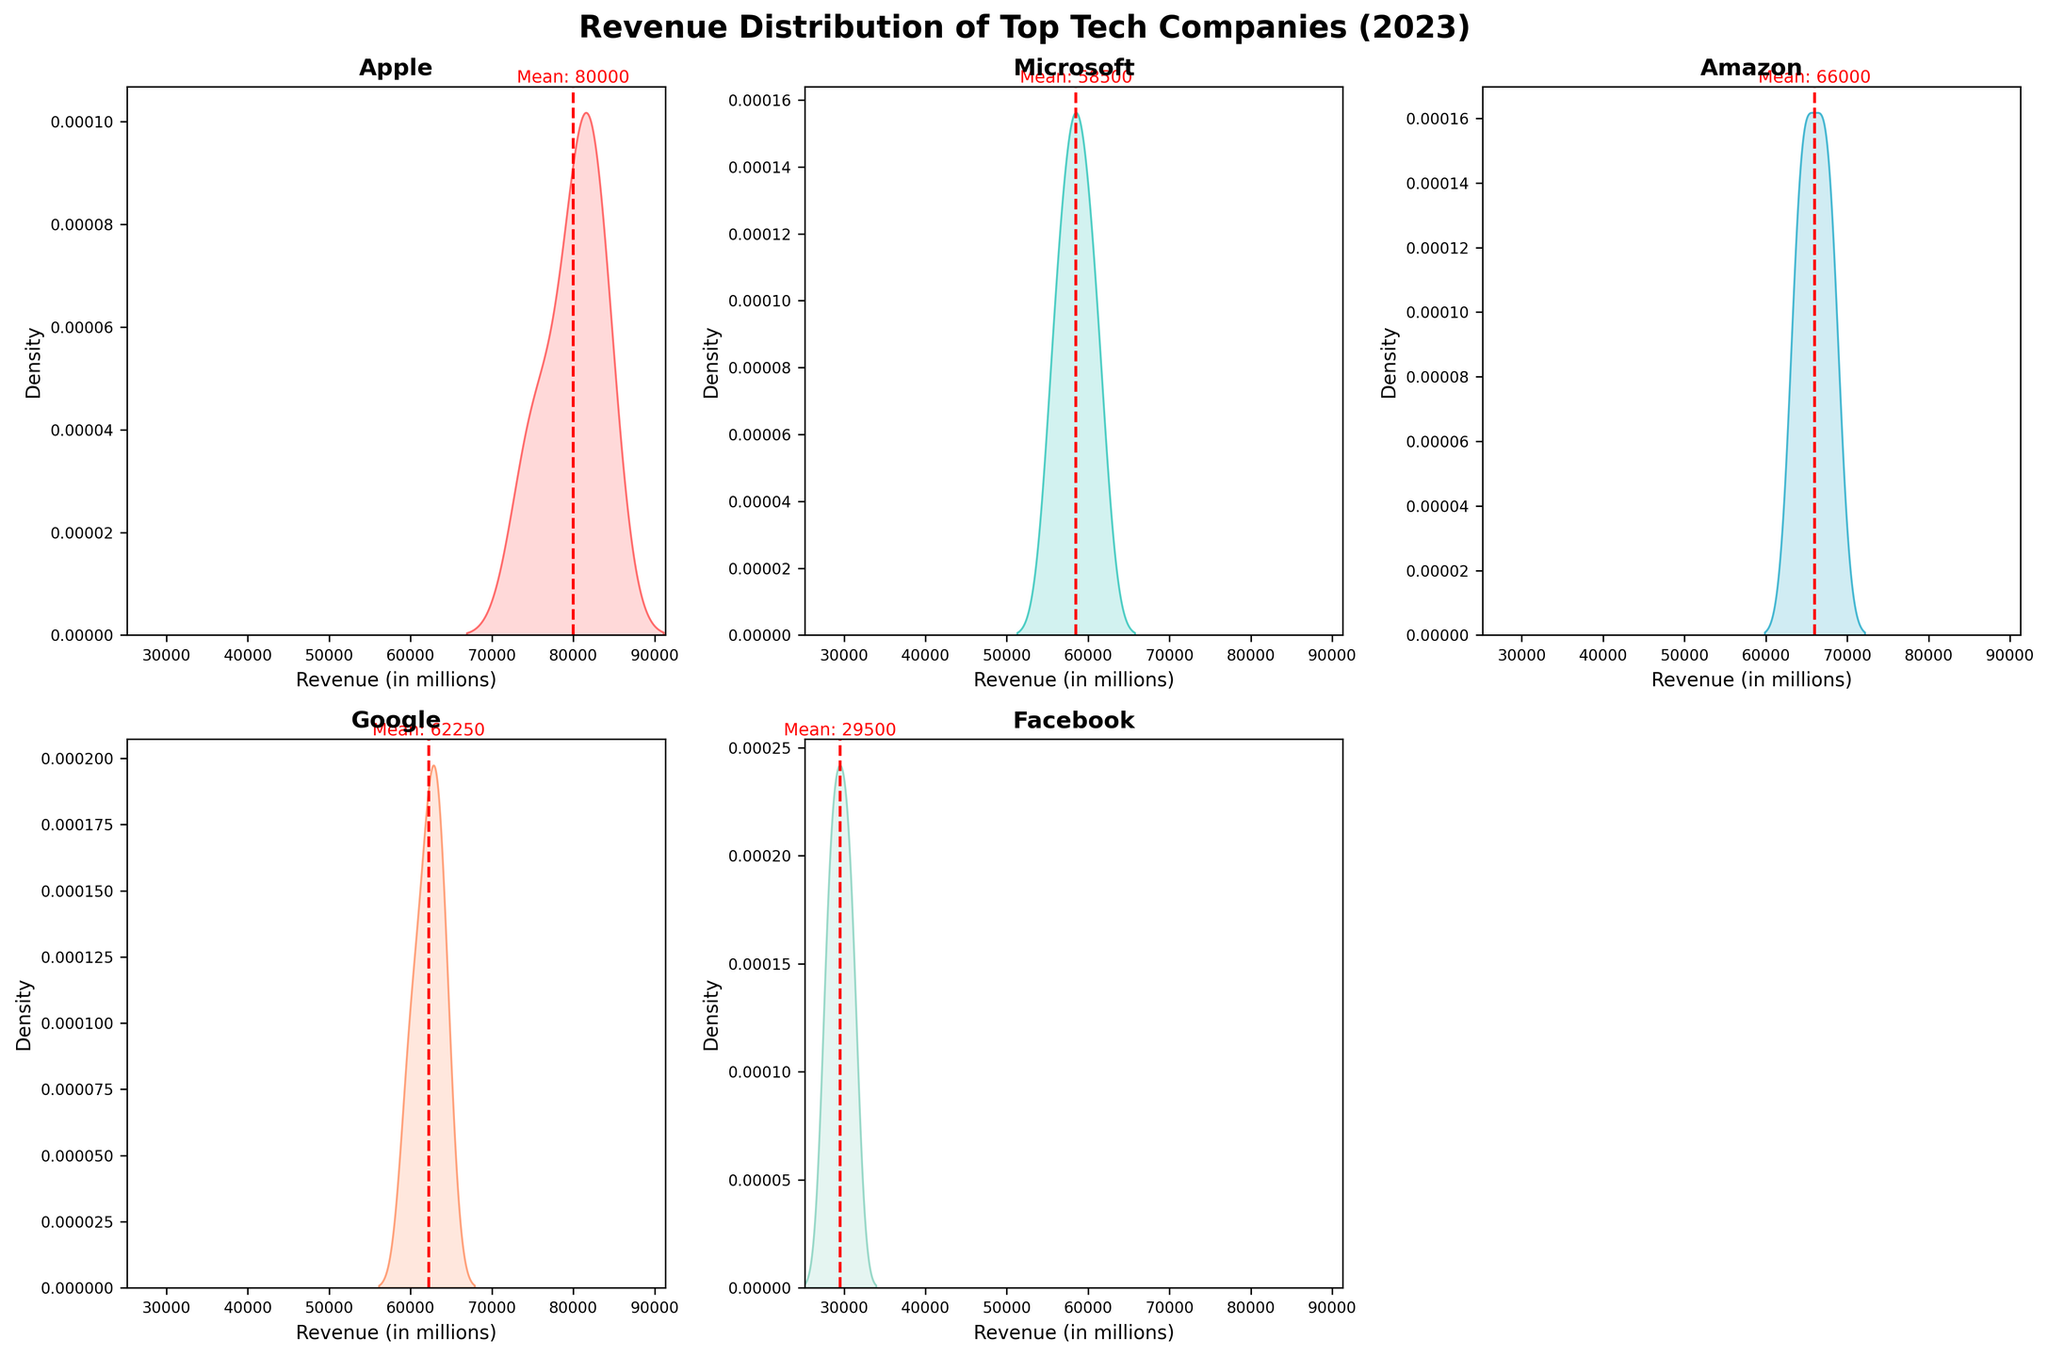which company has the lowest mean revenue Look for the red dashed lines on each subplot representing the mean revenue, and compare their positions. Facebook’s mean revenue, represented by the red dashed line, is the lowest.
Answer: Facebook how many subplots are there in total Count the number of individual density plots on the figure grid. Since the layout is a 2x3 grid, subtracting one empty subplot, there are 5 subplots.
Answer: 5 which company has the highest revenue distribution spread Examine the width of the density plots for each company. Apple’s density plot is the widest, indicating it has the largest spread in revenue distribution.
Answer: Apple what is the revenue mean for google Locate the red dashed line in Google's subplot. There’s a text label near the mean line in Google’s subplot that reads "Mean: 62250".
Answer: 62250 how does apple’s revenue distribution compare to microsoft’s Compare the width and position of the density plots for Apple and Microsoft. Apple’s distribution is wider, indicating more variability, and its mean is higher than Microsoft's.
Answer: Apple’s revenue distribution is wider and has a higher mean compared to Microsoft’s which company’s revenue distribution is the most concentrated Check each subplot for the density plot that is the narrowest. Facebook’s density plot is the narrowest and most concentrated around its mean.
Answer: Facebook which company shows a peak density around 60000 Look for a density peak around the 60000 revenue mark in any subplot. Google’s density plot shows a notable peak around 60000.
Answer: Google do all companies have a revenue mean of over 30000 Check the labeled mean value near the red dashed line in each subplot. All companies except Facebook have a mean above 30000, and Facebook's is below 30000.
Answer: No, Facebook does not what is the color used for amazon's density plot Identify the color representing Amazon in the subplot. Amazon’s density plot is shaded in an orange-like color, similar to the "coral" color used in the custom palette.
Answer: Orange/Coral 